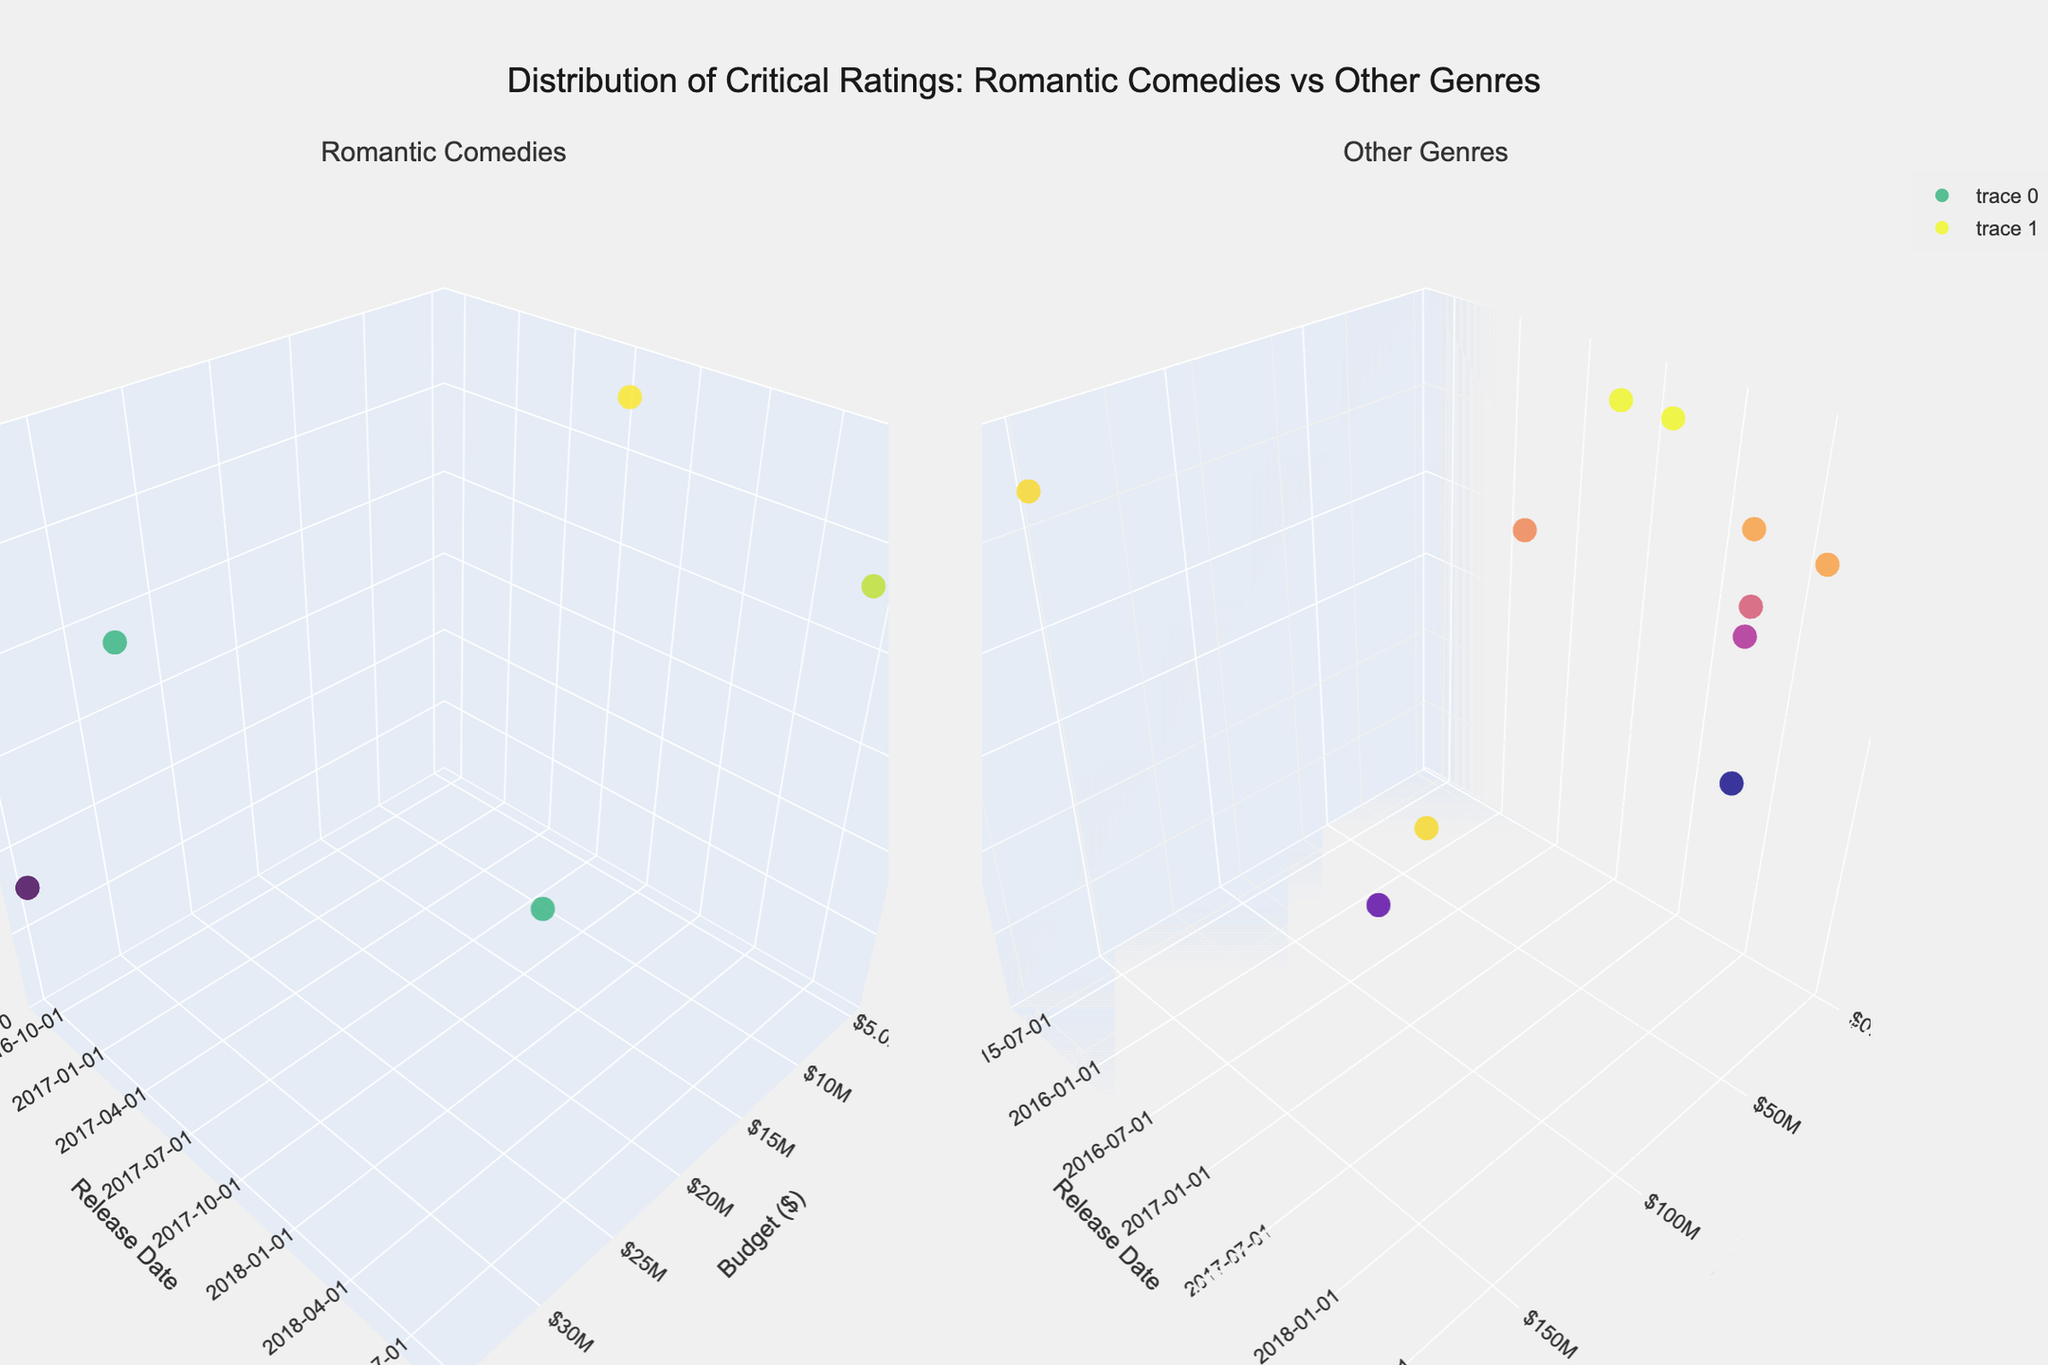How is the title of the figure written? The title of the figure is positioned at the top center. It reads "Distribution of Critical Ratings: Romantic Comedies vs Other Genres".
Answer: Distribution of Critical Ratings: Romantic Comedies vs Other Genres What are the axes titles for both subplots? Both subplots have the same axes titles: "Budget ($)" for the x-axis, "Release Date" for the y-axis, and "Critical Rating" for the z-axis.
Answer: Budget ($), Release Date, Critical Rating How do critical ratings for romantic comedies compare to other genres visually on the plots? Visually, the ratings for romantic comedies are distributed between 78 and 98 on the z-axis, while other genres display a wider spread with ratings ranging from 78 to 98.
Answer: Romantic comedies: 78-98, Other genres: 78-98 Which romantic comedy has the highest critical rating and what is it? By observing the color and height of markers, "The Big Sick" appears to be at the highest position and is also the brightest in the viridis color scale, indicating it has the highest rating.
Answer: The Big Sick (98) Does any romantic comedy have a budget above $40 million? Visual inspection shows that all romantic comedy budget data points lie below the $40 million mark on the x-axis.
Answer: No What is the difference in critical rating between "Mad Max: Fury Road" and "Bridget Jones's Baby"? "Mad Max: Fury Road" is part of the action genre in the right subplot with a rating of 97, and "Bridget Jones's Baby" is in the left subplot for romantic comedies with a rating of 78. The difference is calculated as 97 - 78.
Answer: 19 Which genre shows the highest spending on movie budgets? Observing the scatter points on the x-axis for 'Budget ($)' in both subplots, the action genre, specifically for "Mission: Impossible - Fallout" and "Mad Max: Fury Road," has the highest budgets close to or exceeding $150 million.
Answer: Action How does the critical rating trend change over the release dates for romantic comedies? Observing the left subplot, the critical ratings of romantic comedies seem to stay relatively high (above 75) between 2016 and 2018, showing a consistent distribution.
Answer: Consistent high ratings between 2016-2018 Is there a particular genre in the other subplot with all movies having critical ratings above 90? By examining the right subplot, both horror movies "Get Out" and "A Quiet Place" have ratings above 90, indicating the horror genre's movies in this dataset are rated highly.
Answer: Horror 